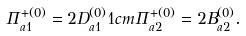Convert formula to latex. <formula><loc_0><loc_0><loc_500><loc_500>\Pi _ { a 1 } ^ { + ( 0 ) } = 2 D _ { a 1 } ^ { ( 0 ) } 1 c m \Pi _ { a 2 } ^ { + ( 0 ) } = 2 B _ { a 2 } ^ { ( 0 ) } .</formula> 